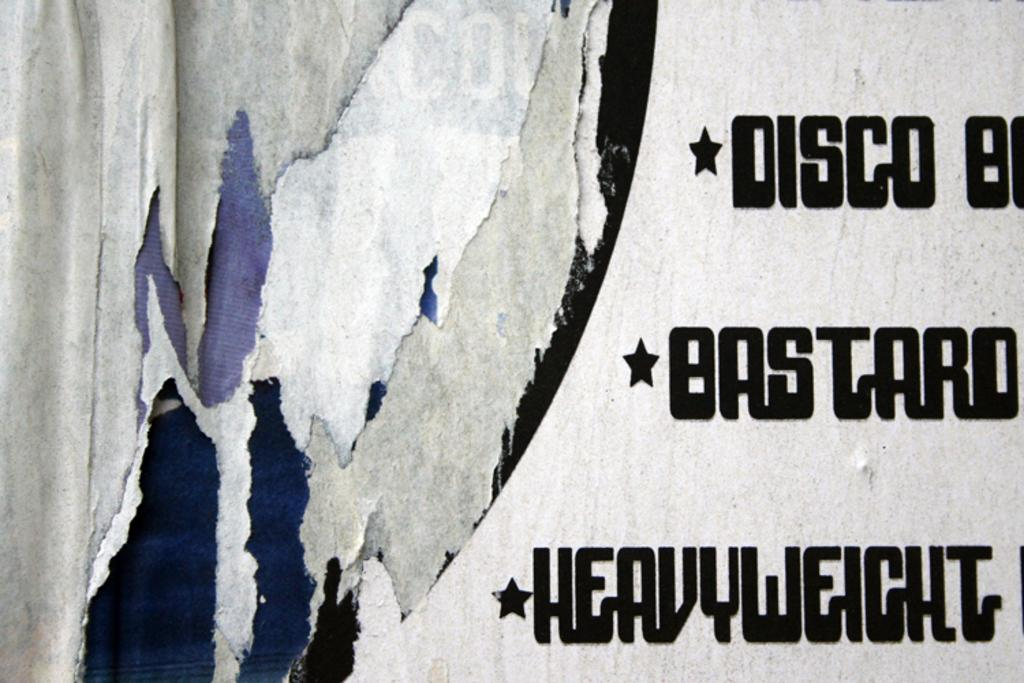Provide a one-sentence caption for the provided image. A sign with whites and blues overlaid on one side has text including heavyweight on the other. 